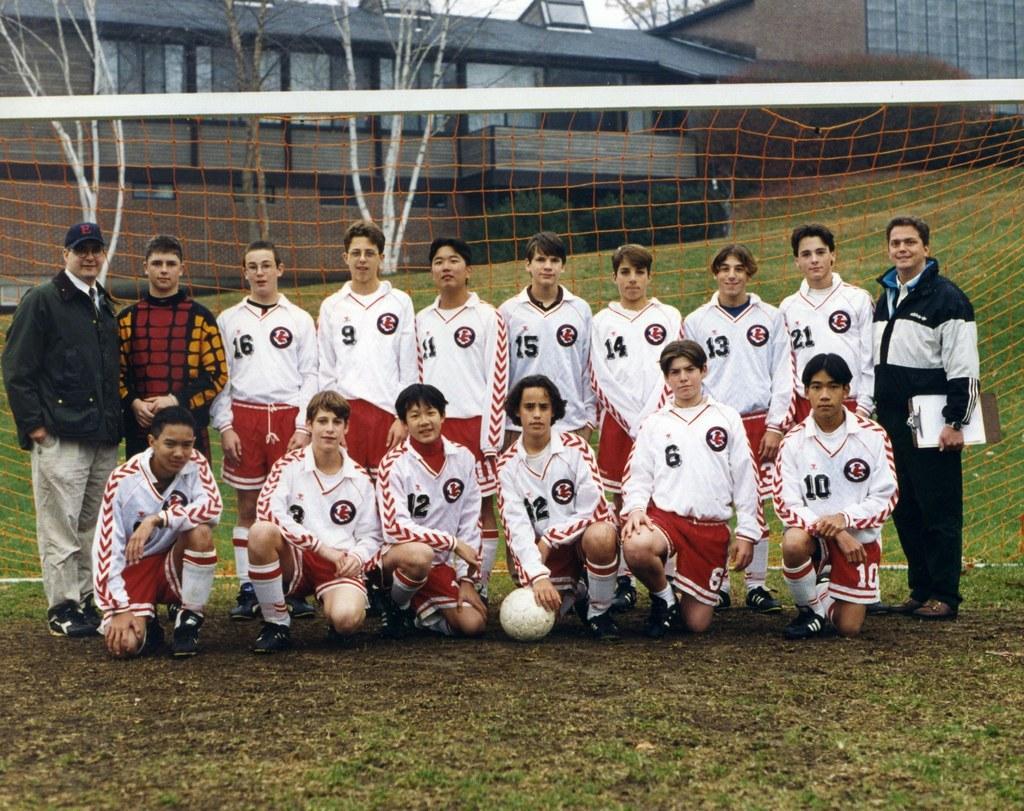Can you describe this image briefly? In this image i can see a football team few of the members are standing behind and some are sitting in front of them. In the background i can see a football net, building, trees and sky. 